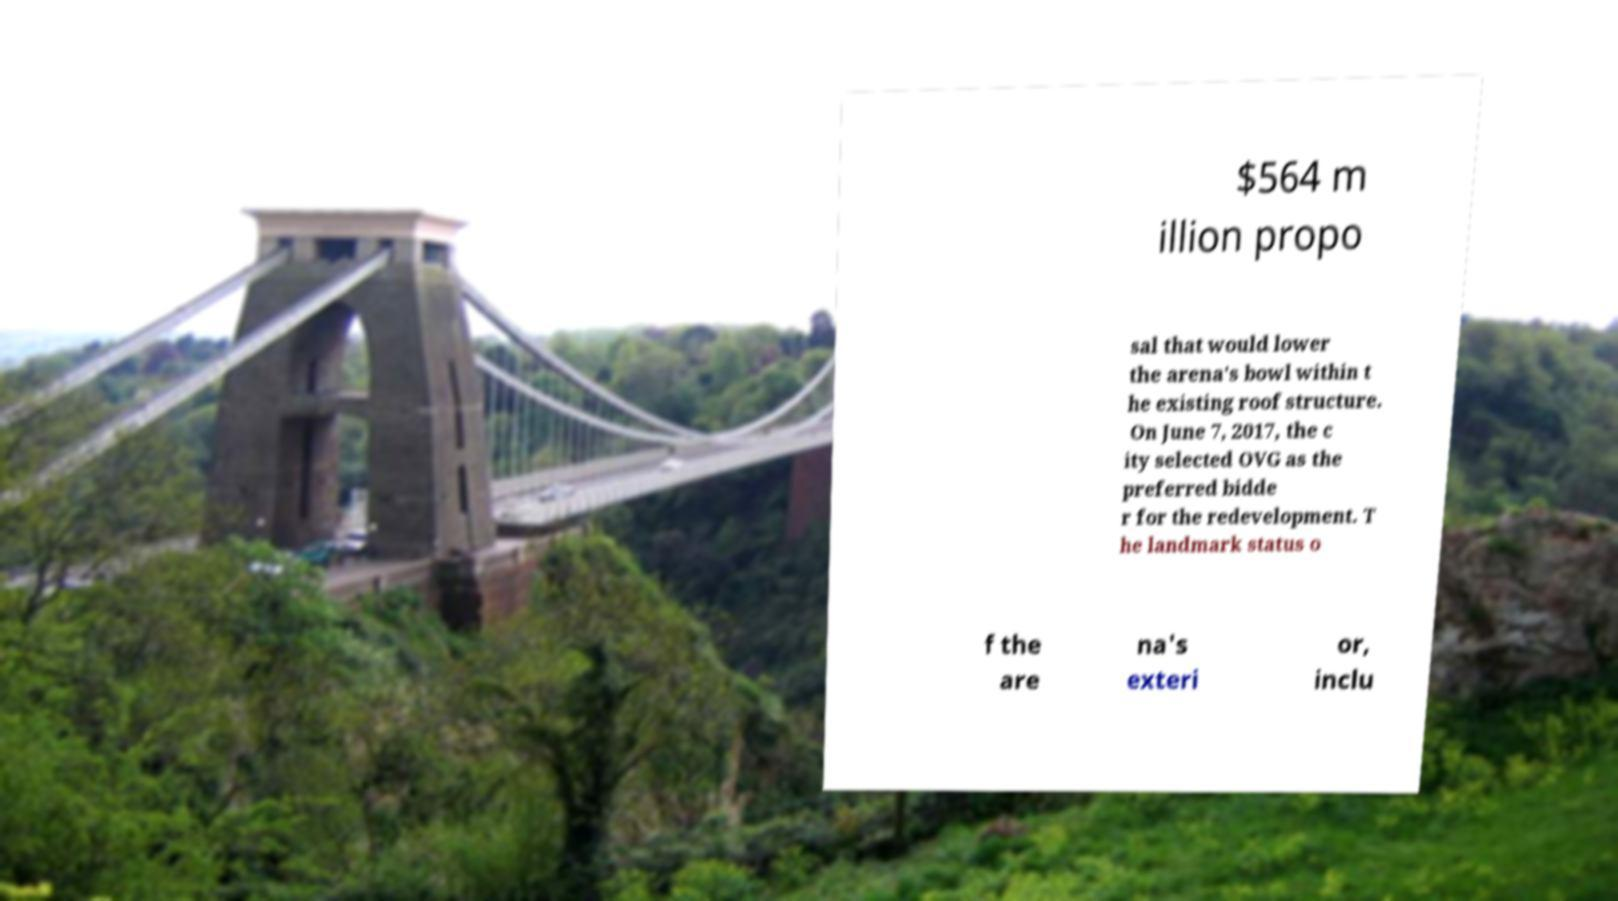Could you extract and type out the text from this image? $564 m illion propo sal that would lower the arena's bowl within t he existing roof structure. On June 7, 2017, the c ity selected OVG as the preferred bidde r for the redevelopment. T he landmark status o f the are na's exteri or, inclu 